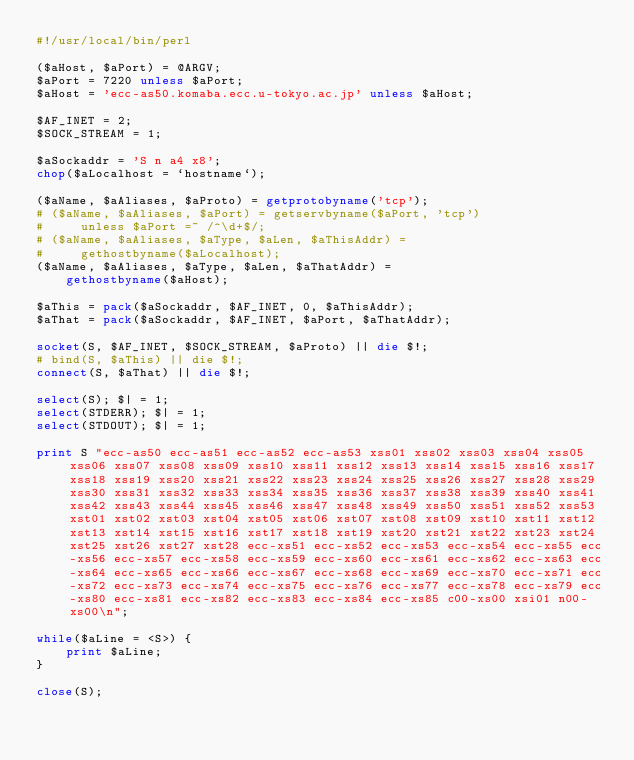<code> <loc_0><loc_0><loc_500><loc_500><_Perl_>#!/usr/local/bin/perl

($aHost, $aPort) = @ARGV;
$aPort = 7220 unless $aPort;
$aHost = 'ecc-as50.komaba.ecc.u-tokyo.ac.jp' unless $aHost;

$AF_INET = 2;
$SOCK_STREAM = 1;

$aSockaddr = 'S n a4 x8';
chop($aLocalhost = `hostname`);

($aName, $aAliases, $aProto) = getprotobyname('tcp');
# ($aName, $aAliases, $aPort) = getservbyname($aPort, 'tcp')
#     unless $aPort =~ /^\d+$/;
# ($aName, $aAliases, $aType, $aLen, $aThisAddr) =
#     gethostbyname($aLocalhost);
($aName, $aAliases, $aType, $aLen, $aThatAddr) =
    gethostbyname($aHost);

$aThis = pack($aSockaddr, $AF_INET, 0, $aThisAddr);
$aThat = pack($aSockaddr, $AF_INET, $aPort, $aThatAddr);

socket(S, $AF_INET, $SOCK_STREAM, $aProto) || die $!;
# bind(S, $aThis) || die $!;
connect(S, $aThat) || die $!;

select(S); $| = 1;
select(STDERR); $| = 1;
select(STDOUT); $| = 1;

print S "ecc-as50 ecc-as51 ecc-as52 ecc-as53 xss01 xss02 xss03 xss04 xss05 xss06 xss07 xss08 xss09 xss10 xss11 xss12 xss13 xss14 xss15 xss16 xss17 xss18 xss19 xss20 xss21 xss22 xss23 xss24 xss25 xss26 xss27 xss28 xss29 xss30 xss31 xss32 xss33 xss34 xss35 xss36 xss37 xss38 xss39 xss40 xss41 xss42 xss43 xss44 xss45 xss46 xss47 xss48 xss49 xss50 xss51 xss52 xss53 xst01 xst02 xst03 xst04 xst05 xst06 xst07 xst08 xst09 xst10 xst11 xst12 xst13 xst14 xst15 xst16 xst17 xst18 xst19 xst20 xst21 xst22 xst23 xst24 xst25 xst26 xst27 xst28 ecc-xs51 ecc-xs52 ecc-xs53 ecc-xs54 ecc-xs55 ecc-xs56 ecc-xs57 ecc-xs58 ecc-xs59 ecc-xs60 ecc-xs61 ecc-xs62 ecc-xs63 ecc-xs64 ecc-xs65 ecc-xs66 ecc-xs67 ecc-xs68 ecc-xs69 ecc-xs70 ecc-xs71 ecc-xs72 ecc-xs73 ecc-xs74 ecc-xs75 ecc-xs76 ecc-xs77 ecc-xs78 ecc-xs79 ecc-xs80 ecc-xs81 ecc-xs82 ecc-xs83 ecc-xs84 ecc-xs85 c00-xs00 xsi01 n00-xs00\n";

while($aLine = <S>) {
    print $aLine;
}

close(S);

</code> 